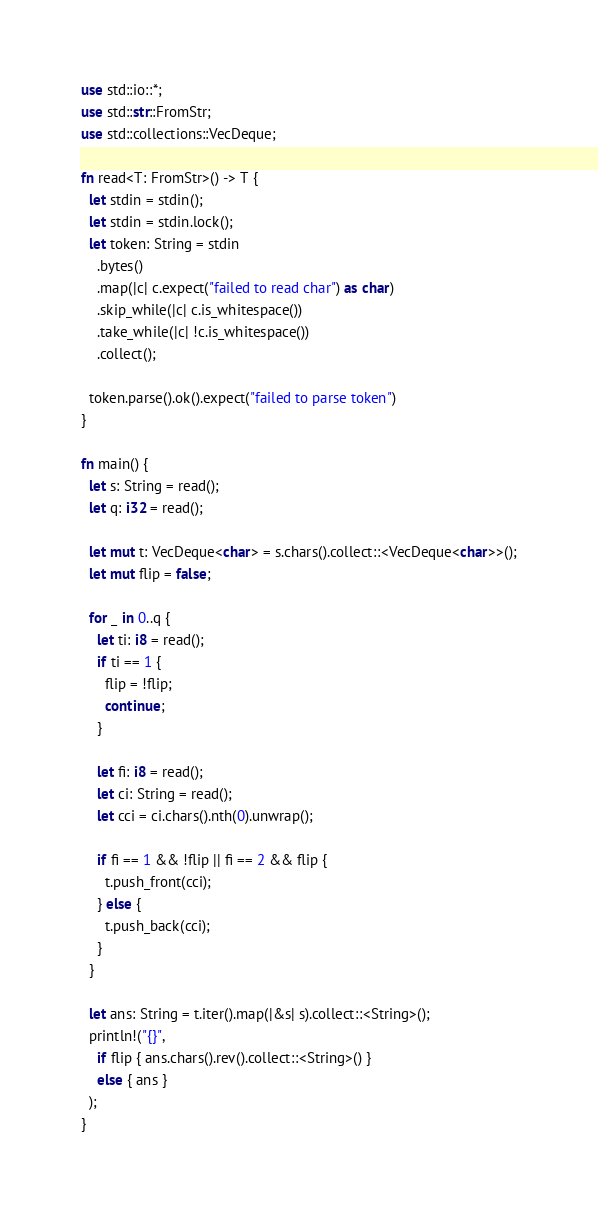Convert code to text. <code><loc_0><loc_0><loc_500><loc_500><_Rust_>use std::io::*;
use std::str::FromStr;
use std::collections::VecDeque;

fn read<T: FromStr>() -> T {
  let stdin = stdin();
  let stdin = stdin.lock();
  let token: String = stdin
    .bytes()
    .map(|c| c.expect("failed to read char") as char) 
    .skip_while(|c| c.is_whitespace())
    .take_while(|c| !c.is_whitespace())
    .collect();
    
  token.parse().ok().expect("failed to parse token")
}

fn main() {
  let s: String = read();
  let q: i32 = read();
 
  let mut t: VecDeque<char> = s.chars().collect::<VecDeque<char>>();
  let mut flip = false;
  
  for _ in 0..q {
    let ti: i8 = read();
    if ti == 1 {
      flip = !flip;
      continue;
    }
    
    let fi: i8 = read();
    let ci: String = read();
    let cci = ci.chars().nth(0).unwrap();
 
    if fi == 1 && !flip || fi == 2 && flip {
      t.push_front(cci);
    } else {
      t.push_back(cci);
    }
  }
  
  let ans: String = t.iter().map(|&s| s).collect::<String>();
  println!("{}",
    if flip { ans.chars().rev().collect::<String>() }
    else { ans }
  );
}</code> 